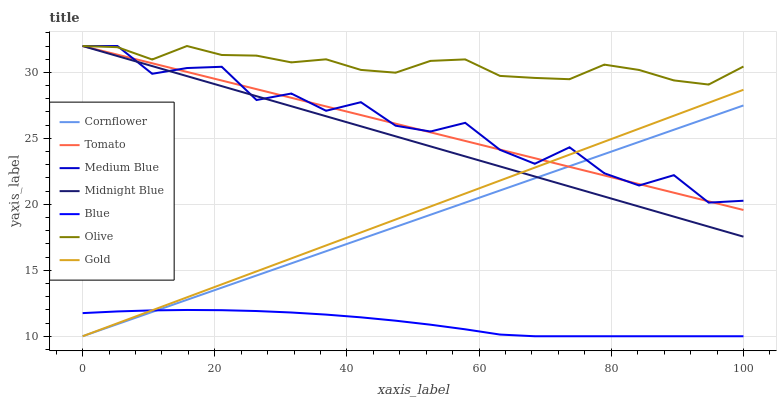Does Blue have the minimum area under the curve?
Answer yes or no. Yes. Does Olive have the maximum area under the curve?
Answer yes or no. Yes. Does Cornflower have the minimum area under the curve?
Answer yes or no. No. Does Cornflower have the maximum area under the curve?
Answer yes or no. No. Is Tomato the smoothest?
Answer yes or no. Yes. Is Medium Blue the roughest?
Answer yes or no. Yes. Is Cornflower the smoothest?
Answer yes or no. No. Is Cornflower the roughest?
Answer yes or no. No. Does Cornflower have the lowest value?
Answer yes or no. Yes. Does Midnight Blue have the lowest value?
Answer yes or no. No. Does Olive have the highest value?
Answer yes or no. Yes. Does Cornflower have the highest value?
Answer yes or no. No. Is Blue less than Medium Blue?
Answer yes or no. Yes. Is Medium Blue greater than Blue?
Answer yes or no. Yes. Does Tomato intersect Olive?
Answer yes or no. Yes. Is Tomato less than Olive?
Answer yes or no. No. Is Tomato greater than Olive?
Answer yes or no. No. Does Blue intersect Medium Blue?
Answer yes or no. No. 